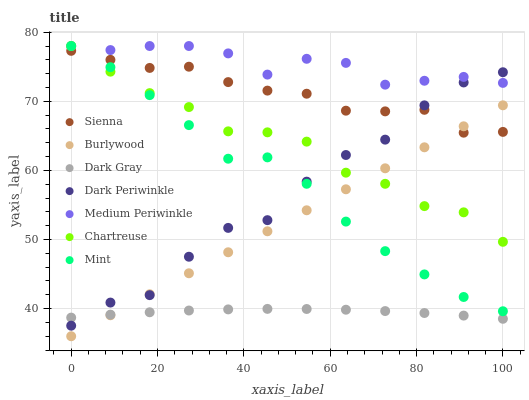Does Dark Gray have the minimum area under the curve?
Answer yes or no. Yes. Does Medium Periwinkle have the maximum area under the curve?
Answer yes or no. Yes. Does Burlywood have the minimum area under the curve?
Answer yes or no. No. Does Burlywood have the maximum area under the curve?
Answer yes or no. No. Is Burlywood the smoothest?
Answer yes or no. Yes. Is Dark Periwinkle the roughest?
Answer yes or no. Yes. Is Medium Periwinkle the smoothest?
Answer yes or no. No. Is Medium Periwinkle the roughest?
Answer yes or no. No. Does Burlywood have the lowest value?
Answer yes or no. Yes. Does Medium Periwinkle have the lowest value?
Answer yes or no. No. Does Mint have the highest value?
Answer yes or no. Yes. Does Burlywood have the highest value?
Answer yes or no. No. Is Sienna less than Medium Periwinkle?
Answer yes or no. Yes. Is Sienna greater than Dark Gray?
Answer yes or no. Yes. Does Burlywood intersect Sienna?
Answer yes or no. Yes. Is Burlywood less than Sienna?
Answer yes or no. No. Is Burlywood greater than Sienna?
Answer yes or no. No. Does Sienna intersect Medium Periwinkle?
Answer yes or no. No. 